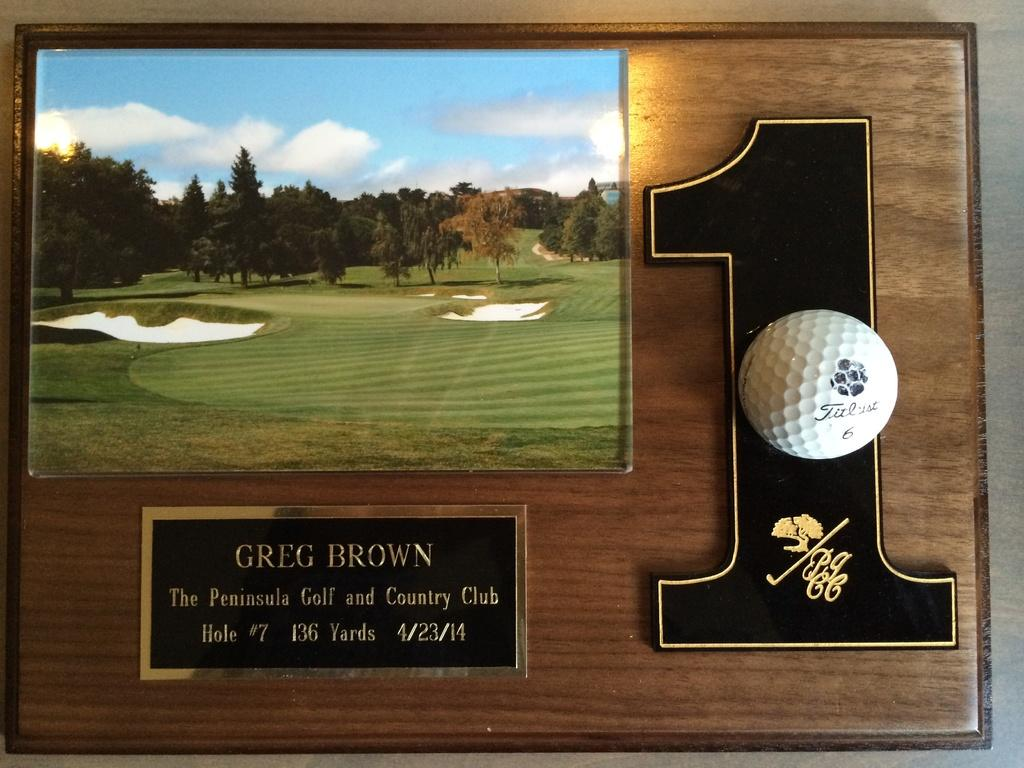<image>
Create a compact narrative representing the image presented. hole in one award to greg brown from the peninsula golf and country club 